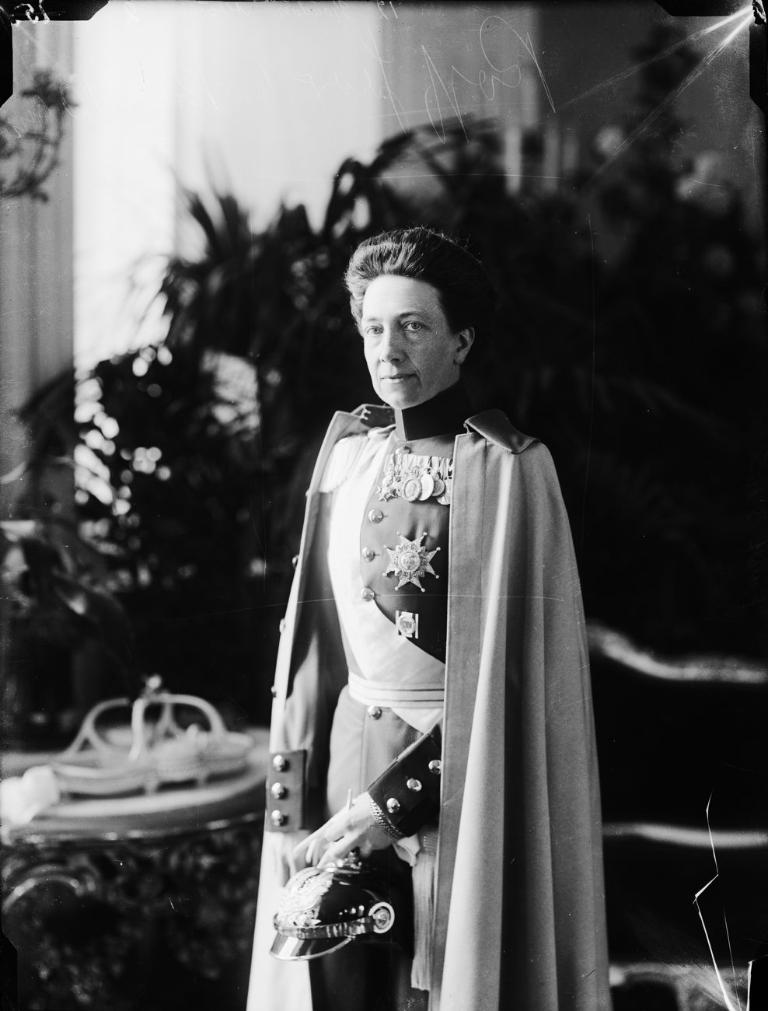What is the color scheme of the image? The image is black and white. Who is present in the image? There is a man in the image. What is the man wearing? The man is wearing a uniform. What can be seen in the background of the image? There are plants visible in the background of the image. What type of soup is being served in the image? There is no soup present in the image; it is a black and white image of a man wearing a uniform with plants in the background. What kind of thread is being used to sew the man's uniform in the image? There is no information about the type of thread used to sew the man's uniform in the image. 